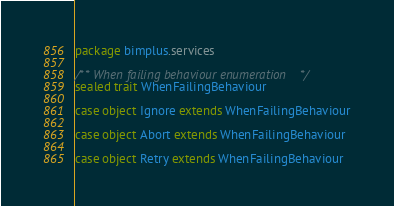Convert code to text. <code><loc_0><loc_0><loc_500><loc_500><_Scala_>package bimplus.services

/** When failing behaviour enumeration */
sealed trait WhenFailingBehaviour

case object Ignore extends WhenFailingBehaviour

case object Abort extends WhenFailingBehaviour

case object Retry extends WhenFailingBehaviour</code> 